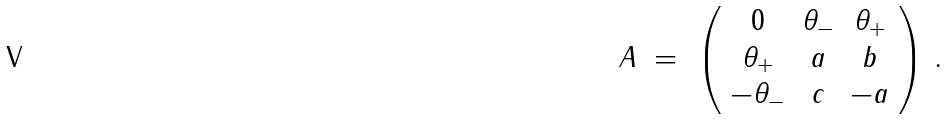Convert formula to latex. <formula><loc_0><loc_0><loc_500><loc_500>A \ = \ \left ( \begin{array} { c c c } 0 & \theta _ { - } & \theta _ { + } \\ \theta _ { + } & a & b \\ - \theta _ { - } & c & - a \end{array} \right ) \, .</formula> 